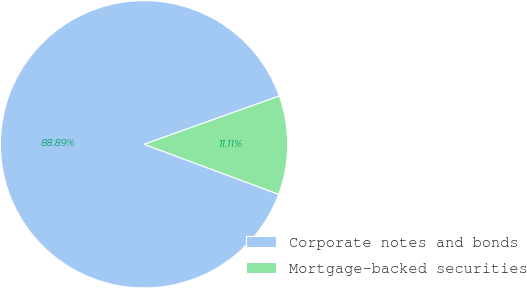Convert chart. <chart><loc_0><loc_0><loc_500><loc_500><pie_chart><fcel>Corporate notes and bonds<fcel>Mortgage-backed securities<nl><fcel>88.89%<fcel>11.11%<nl></chart> 